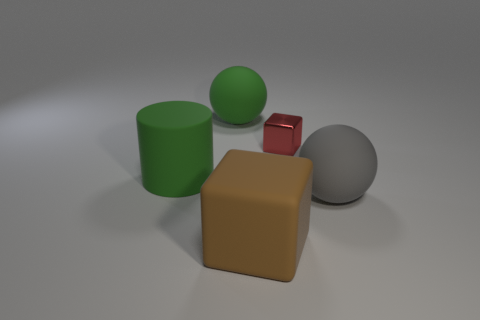Add 4 big gray spheres. How many objects exist? 9 Subtract all cylinders. How many objects are left? 4 Add 5 big yellow rubber things. How many big yellow rubber things exist? 5 Subtract 1 green balls. How many objects are left? 4 Subtract all spheres. Subtract all large gray things. How many objects are left? 2 Add 2 matte objects. How many matte objects are left? 6 